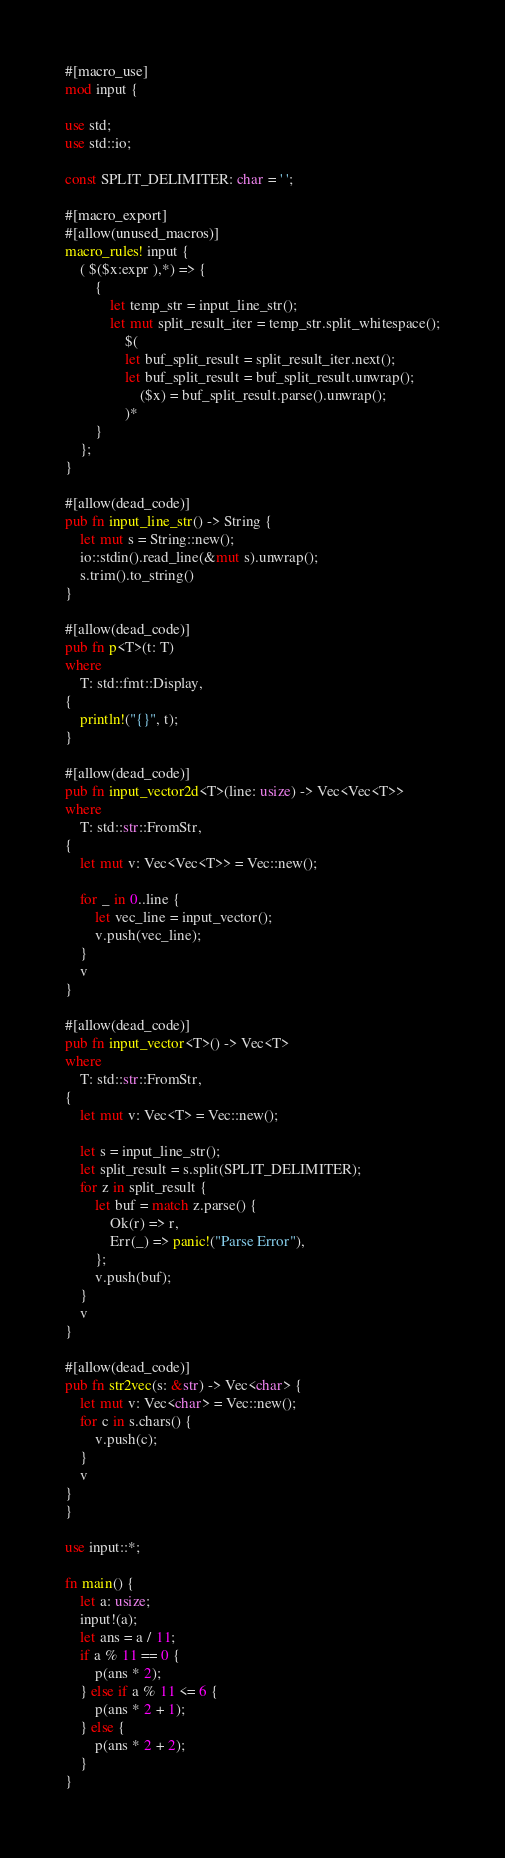Convert code to text. <code><loc_0><loc_0><loc_500><loc_500><_Rust_>#[macro_use]
mod input {

use std;
use std::io;

const SPLIT_DELIMITER: char = ' ';

#[macro_export]
#[allow(unused_macros)]
macro_rules! input {
    ( $($x:expr ),*) => {
        {
            let temp_str = input_line_str();
            let mut split_result_iter = temp_str.split_whitespace();
                $(
                let buf_split_result = split_result_iter.next();
                let buf_split_result = buf_split_result.unwrap();
                    ($x) = buf_split_result.parse().unwrap();
                )*
        }
    };
}

#[allow(dead_code)]
pub fn input_line_str() -> String {
    let mut s = String::new();
    io::stdin().read_line(&mut s).unwrap();
    s.trim().to_string()
}

#[allow(dead_code)]
pub fn p<T>(t: T)
where
    T: std::fmt::Display,
{
    println!("{}", t);
}

#[allow(dead_code)]
pub fn input_vector2d<T>(line: usize) -> Vec<Vec<T>>
where
    T: std::str::FromStr,
{
    let mut v: Vec<Vec<T>> = Vec::new();

    for _ in 0..line {
        let vec_line = input_vector();
        v.push(vec_line);
    }
    v
}

#[allow(dead_code)]
pub fn input_vector<T>() -> Vec<T>
where
    T: std::str::FromStr,
{
    let mut v: Vec<T> = Vec::new();

    let s = input_line_str();
    let split_result = s.split(SPLIT_DELIMITER);
    for z in split_result {
        let buf = match z.parse() {
            Ok(r) => r,
            Err(_) => panic!("Parse Error"),
        };
        v.push(buf);
    }
    v
}

#[allow(dead_code)]
pub fn str2vec(s: &str) -> Vec<char> {
    let mut v: Vec<char> = Vec::new();
    for c in s.chars() {
        v.push(c);
    }
    v
}
}

use input::*;

fn main() {
    let a: usize;
    input!(a);
    let ans = a / 11;
    if a % 11 == 0 {
        p(ans * 2);
    } else if a % 11 <= 6 {
        p(ans * 2 + 1);
    } else {
        p(ans * 2 + 2);
    }
}</code> 